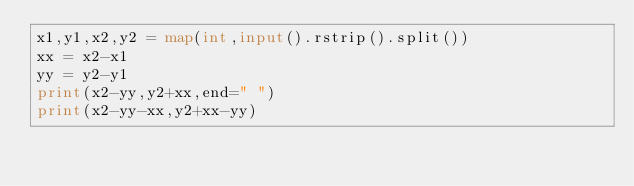Convert code to text. <code><loc_0><loc_0><loc_500><loc_500><_Python_>x1,y1,x2,y2 = map(int,input().rstrip().split())
xx = x2-x1
yy = y2-y1
print(x2-yy,y2+xx,end=" ")
print(x2-yy-xx,y2+xx-yy)
</code> 